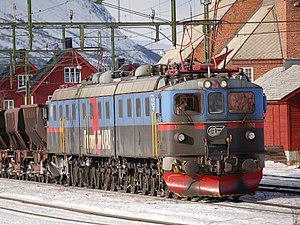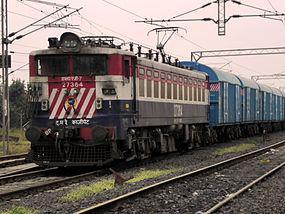The first image is the image on the left, the second image is the image on the right. Given the left and right images, does the statement "There are two trains in total traveling in opposite direction." hold true? Answer yes or no. Yes. The first image is the image on the left, the second image is the image on the right. Analyze the images presented: Is the assertion "There are multiple trains in the image on the left." valid? Answer yes or no. No. 